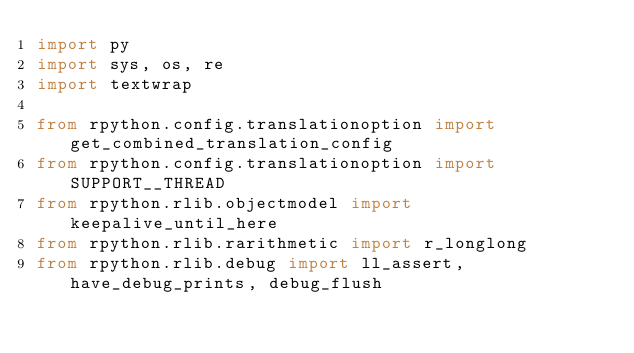<code> <loc_0><loc_0><loc_500><loc_500><_Python_>import py
import sys, os, re
import textwrap

from rpython.config.translationoption import get_combined_translation_config
from rpython.config.translationoption import SUPPORT__THREAD
from rpython.rlib.objectmodel import keepalive_until_here
from rpython.rlib.rarithmetic import r_longlong
from rpython.rlib.debug import ll_assert, have_debug_prints, debug_flush</code> 